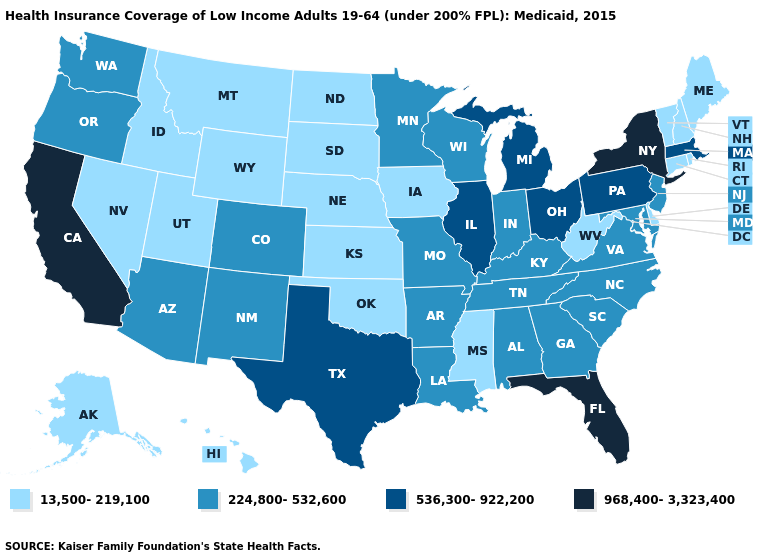Name the states that have a value in the range 536,300-922,200?
Answer briefly. Illinois, Massachusetts, Michigan, Ohio, Pennsylvania, Texas. Which states have the highest value in the USA?
Write a very short answer. California, Florida, New York. What is the value of Tennessee?
Short answer required. 224,800-532,600. Name the states that have a value in the range 968,400-3,323,400?
Be succinct. California, Florida, New York. What is the lowest value in the MidWest?
Write a very short answer. 13,500-219,100. Name the states that have a value in the range 224,800-532,600?
Keep it brief. Alabama, Arizona, Arkansas, Colorado, Georgia, Indiana, Kentucky, Louisiana, Maryland, Minnesota, Missouri, New Jersey, New Mexico, North Carolina, Oregon, South Carolina, Tennessee, Virginia, Washington, Wisconsin. What is the value of West Virginia?
Quick response, please. 13,500-219,100. What is the value of Florida?
Concise answer only. 968,400-3,323,400. What is the value of Indiana?
Give a very brief answer. 224,800-532,600. Name the states that have a value in the range 536,300-922,200?
Keep it brief. Illinois, Massachusetts, Michigan, Ohio, Pennsylvania, Texas. Does the first symbol in the legend represent the smallest category?
Give a very brief answer. Yes. Is the legend a continuous bar?
Give a very brief answer. No. Does Tennessee have the lowest value in the USA?
Short answer required. No. What is the value of Rhode Island?
Concise answer only. 13,500-219,100. 